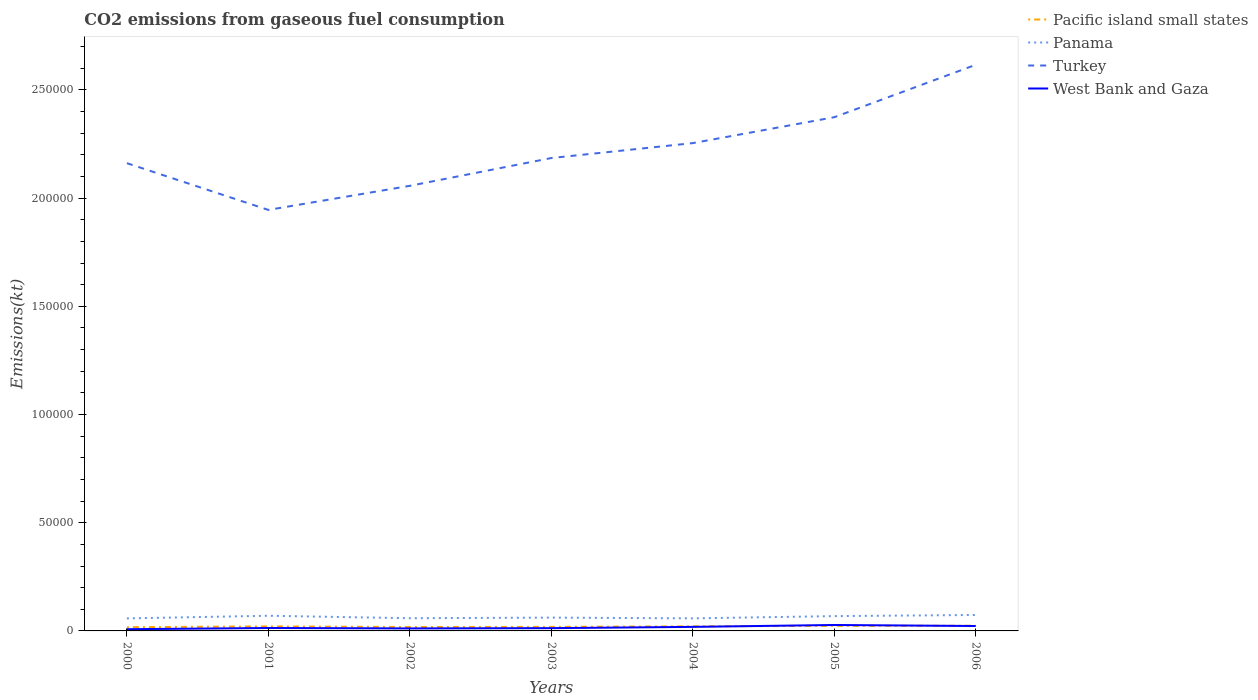How many different coloured lines are there?
Provide a succinct answer. 4. Does the line corresponding to Turkey intersect with the line corresponding to Pacific island small states?
Ensure brevity in your answer.  No. Across all years, what is the maximum amount of CO2 emitted in West Bank and Gaza?
Provide a succinct answer. 792.07. In which year was the amount of CO2 emitted in Turkey maximum?
Keep it short and to the point. 2001. What is the total amount of CO2 emitted in Pacific island small states in the graph?
Your answer should be very brief. -254.8. What is the difference between the highest and the second highest amount of CO2 emitted in West Bank and Gaza?
Keep it short and to the point. 1950.84. Is the amount of CO2 emitted in Turkey strictly greater than the amount of CO2 emitted in West Bank and Gaza over the years?
Your answer should be very brief. No. How many lines are there?
Offer a terse response. 4. Does the graph contain grids?
Your answer should be very brief. No. Where does the legend appear in the graph?
Offer a terse response. Top right. How many legend labels are there?
Keep it short and to the point. 4. How are the legend labels stacked?
Keep it short and to the point. Vertical. What is the title of the graph?
Provide a short and direct response. CO2 emissions from gaseous fuel consumption. Does "Marshall Islands" appear as one of the legend labels in the graph?
Provide a succinct answer. No. What is the label or title of the Y-axis?
Provide a short and direct response. Emissions(kt). What is the Emissions(kt) in Pacific island small states in 2000?
Provide a succinct answer. 1720.84. What is the Emissions(kt) in Panama in 2000?
Offer a very short reply. 5790.19. What is the Emissions(kt) in Turkey in 2000?
Provide a succinct answer. 2.16e+05. What is the Emissions(kt) of West Bank and Gaza in 2000?
Provide a short and direct response. 792.07. What is the Emissions(kt) in Pacific island small states in 2001?
Make the answer very short. 2086.43. What is the Emissions(kt) in Panama in 2001?
Your response must be concise. 7007.64. What is the Emissions(kt) in Turkey in 2001?
Your answer should be very brief. 1.95e+05. What is the Emissions(kt) in West Bank and Gaza in 2001?
Offer a terse response. 1349.46. What is the Emissions(kt) in Pacific island small states in 2002?
Your response must be concise. 1805.78. What is the Emissions(kt) in Panama in 2002?
Keep it short and to the point. 5870.87. What is the Emissions(kt) of Turkey in 2002?
Make the answer very short. 2.06e+05. What is the Emissions(kt) in West Bank and Gaza in 2002?
Your response must be concise. 1155.11. What is the Emissions(kt) in Pacific island small states in 2003?
Make the answer very short. 1864.86. What is the Emissions(kt) of Panama in 2003?
Your response must be concise. 6153.23. What is the Emissions(kt) of Turkey in 2003?
Ensure brevity in your answer.  2.19e+05. What is the Emissions(kt) in West Bank and Gaza in 2003?
Your response must be concise. 1279.78. What is the Emissions(kt) in Pacific island small states in 2004?
Your answer should be very brief. 2119.67. What is the Emissions(kt) in Panama in 2004?
Make the answer very short. 5804.86. What is the Emissions(kt) of Turkey in 2004?
Keep it short and to the point. 2.25e+05. What is the Emissions(kt) of West Bank and Gaza in 2004?
Your answer should be compact. 1866.5. What is the Emissions(kt) in Pacific island small states in 2005?
Make the answer very short. 2356.01. What is the Emissions(kt) in Panama in 2005?
Your answer should be very brief. 6838.95. What is the Emissions(kt) of Turkey in 2005?
Offer a terse response. 2.37e+05. What is the Emissions(kt) in West Bank and Gaza in 2005?
Offer a very short reply. 2742.92. What is the Emissions(kt) of Pacific island small states in 2006?
Offer a terse response. 2396.63. What is the Emissions(kt) in Panama in 2006?
Offer a very short reply. 7370.67. What is the Emissions(kt) in Turkey in 2006?
Your answer should be compact. 2.62e+05. What is the Emissions(kt) of West Bank and Gaza in 2006?
Provide a succinct answer. 2266.21. Across all years, what is the maximum Emissions(kt) in Pacific island small states?
Ensure brevity in your answer.  2396.63. Across all years, what is the maximum Emissions(kt) of Panama?
Offer a very short reply. 7370.67. Across all years, what is the maximum Emissions(kt) of Turkey?
Offer a very short reply. 2.62e+05. Across all years, what is the maximum Emissions(kt) of West Bank and Gaza?
Ensure brevity in your answer.  2742.92. Across all years, what is the minimum Emissions(kt) of Pacific island small states?
Provide a succinct answer. 1720.84. Across all years, what is the minimum Emissions(kt) of Panama?
Your answer should be very brief. 5790.19. Across all years, what is the minimum Emissions(kt) of Turkey?
Offer a terse response. 1.95e+05. Across all years, what is the minimum Emissions(kt) of West Bank and Gaza?
Provide a short and direct response. 792.07. What is the total Emissions(kt) in Pacific island small states in the graph?
Offer a very short reply. 1.44e+04. What is the total Emissions(kt) of Panama in the graph?
Keep it short and to the point. 4.48e+04. What is the total Emissions(kt) in Turkey in the graph?
Give a very brief answer. 1.56e+06. What is the total Emissions(kt) in West Bank and Gaza in the graph?
Ensure brevity in your answer.  1.15e+04. What is the difference between the Emissions(kt) of Pacific island small states in 2000 and that in 2001?
Make the answer very short. -365.59. What is the difference between the Emissions(kt) of Panama in 2000 and that in 2001?
Your response must be concise. -1217.44. What is the difference between the Emissions(kt) in Turkey in 2000 and that in 2001?
Offer a very short reply. 2.16e+04. What is the difference between the Emissions(kt) of West Bank and Gaza in 2000 and that in 2001?
Provide a succinct answer. -557.38. What is the difference between the Emissions(kt) in Pacific island small states in 2000 and that in 2002?
Provide a short and direct response. -84.93. What is the difference between the Emissions(kt) in Panama in 2000 and that in 2002?
Give a very brief answer. -80.67. What is the difference between the Emissions(kt) of Turkey in 2000 and that in 2002?
Offer a very short reply. 1.05e+04. What is the difference between the Emissions(kt) in West Bank and Gaza in 2000 and that in 2002?
Your response must be concise. -363.03. What is the difference between the Emissions(kt) of Pacific island small states in 2000 and that in 2003?
Make the answer very short. -144.02. What is the difference between the Emissions(kt) in Panama in 2000 and that in 2003?
Provide a short and direct response. -363.03. What is the difference between the Emissions(kt) of Turkey in 2000 and that in 2003?
Your answer should be compact. -2372.55. What is the difference between the Emissions(kt) of West Bank and Gaza in 2000 and that in 2003?
Keep it short and to the point. -487.71. What is the difference between the Emissions(kt) in Pacific island small states in 2000 and that in 2004?
Ensure brevity in your answer.  -398.82. What is the difference between the Emissions(kt) of Panama in 2000 and that in 2004?
Provide a short and direct response. -14.67. What is the difference between the Emissions(kt) in Turkey in 2000 and that in 2004?
Provide a succinct answer. -9270.18. What is the difference between the Emissions(kt) of West Bank and Gaza in 2000 and that in 2004?
Keep it short and to the point. -1074.43. What is the difference between the Emissions(kt) of Pacific island small states in 2000 and that in 2005?
Offer a terse response. -635.16. What is the difference between the Emissions(kt) of Panama in 2000 and that in 2005?
Offer a very short reply. -1048.76. What is the difference between the Emissions(kt) of Turkey in 2000 and that in 2005?
Provide a short and direct response. -2.12e+04. What is the difference between the Emissions(kt) of West Bank and Gaza in 2000 and that in 2005?
Offer a very short reply. -1950.84. What is the difference between the Emissions(kt) of Pacific island small states in 2000 and that in 2006?
Your answer should be compact. -675.78. What is the difference between the Emissions(kt) in Panama in 2000 and that in 2006?
Give a very brief answer. -1580.48. What is the difference between the Emissions(kt) of Turkey in 2000 and that in 2006?
Give a very brief answer. -4.55e+04. What is the difference between the Emissions(kt) of West Bank and Gaza in 2000 and that in 2006?
Make the answer very short. -1474.13. What is the difference between the Emissions(kt) of Pacific island small states in 2001 and that in 2002?
Offer a very short reply. 280.65. What is the difference between the Emissions(kt) in Panama in 2001 and that in 2002?
Your answer should be compact. 1136.77. What is the difference between the Emissions(kt) in Turkey in 2001 and that in 2002?
Keep it short and to the point. -1.11e+04. What is the difference between the Emissions(kt) in West Bank and Gaza in 2001 and that in 2002?
Offer a very short reply. 194.35. What is the difference between the Emissions(kt) of Pacific island small states in 2001 and that in 2003?
Your answer should be very brief. 221.57. What is the difference between the Emissions(kt) in Panama in 2001 and that in 2003?
Offer a very short reply. 854.41. What is the difference between the Emissions(kt) in Turkey in 2001 and that in 2003?
Ensure brevity in your answer.  -2.40e+04. What is the difference between the Emissions(kt) in West Bank and Gaza in 2001 and that in 2003?
Provide a short and direct response. 69.67. What is the difference between the Emissions(kt) of Pacific island small states in 2001 and that in 2004?
Provide a short and direct response. -33.24. What is the difference between the Emissions(kt) in Panama in 2001 and that in 2004?
Keep it short and to the point. 1202.78. What is the difference between the Emissions(kt) of Turkey in 2001 and that in 2004?
Make the answer very short. -3.09e+04. What is the difference between the Emissions(kt) in West Bank and Gaza in 2001 and that in 2004?
Ensure brevity in your answer.  -517.05. What is the difference between the Emissions(kt) of Pacific island small states in 2001 and that in 2005?
Your response must be concise. -269.57. What is the difference between the Emissions(kt) of Panama in 2001 and that in 2005?
Give a very brief answer. 168.68. What is the difference between the Emissions(kt) in Turkey in 2001 and that in 2005?
Your response must be concise. -4.28e+04. What is the difference between the Emissions(kt) of West Bank and Gaza in 2001 and that in 2005?
Your answer should be compact. -1393.46. What is the difference between the Emissions(kt) of Pacific island small states in 2001 and that in 2006?
Keep it short and to the point. -310.2. What is the difference between the Emissions(kt) in Panama in 2001 and that in 2006?
Ensure brevity in your answer.  -363.03. What is the difference between the Emissions(kt) in Turkey in 2001 and that in 2006?
Make the answer very short. -6.71e+04. What is the difference between the Emissions(kt) of West Bank and Gaza in 2001 and that in 2006?
Provide a succinct answer. -916.75. What is the difference between the Emissions(kt) of Pacific island small states in 2002 and that in 2003?
Give a very brief answer. -59.08. What is the difference between the Emissions(kt) of Panama in 2002 and that in 2003?
Offer a very short reply. -282.36. What is the difference between the Emissions(kt) of Turkey in 2002 and that in 2003?
Make the answer very short. -1.28e+04. What is the difference between the Emissions(kt) of West Bank and Gaza in 2002 and that in 2003?
Keep it short and to the point. -124.68. What is the difference between the Emissions(kt) of Pacific island small states in 2002 and that in 2004?
Make the answer very short. -313.89. What is the difference between the Emissions(kt) in Panama in 2002 and that in 2004?
Provide a succinct answer. 66.01. What is the difference between the Emissions(kt) in Turkey in 2002 and that in 2004?
Your answer should be very brief. -1.97e+04. What is the difference between the Emissions(kt) of West Bank and Gaza in 2002 and that in 2004?
Make the answer very short. -711.4. What is the difference between the Emissions(kt) in Pacific island small states in 2002 and that in 2005?
Your answer should be compact. -550.23. What is the difference between the Emissions(kt) of Panama in 2002 and that in 2005?
Make the answer very short. -968.09. What is the difference between the Emissions(kt) in Turkey in 2002 and that in 2005?
Keep it short and to the point. -3.17e+04. What is the difference between the Emissions(kt) in West Bank and Gaza in 2002 and that in 2005?
Make the answer very short. -1587.81. What is the difference between the Emissions(kt) in Pacific island small states in 2002 and that in 2006?
Make the answer very short. -590.85. What is the difference between the Emissions(kt) of Panama in 2002 and that in 2006?
Offer a very short reply. -1499.8. What is the difference between the Emissions(kt) in Turkey in 2002 and that in 2006?
Provide a short and direct response. -5.59e+04. What is the difference between the Emissions(kt) of West Bank and Gaza in 2002 and that in 2006?
Give a very brief answer. -1111.1. What is the difference between the Emissions(kt) in Pacific island small states in 2003 and that in 2004?
Your response must be concise. -254.8. What is the difference between the Emissions(kt) in Panama in 2003 and that in 2004?
Give a very brief answer. 348.37. What is the difference between the Emissions(kt) in Turkey in 2003 and that in 2004?
Offer a terse response. -6897.63. What is the difference between the Emissions(kt) of West Bank and Gaza in 2003 and that in 2004?
Offer a very short reply. -586.72. What is the difference between the Emissions(kt) in Pacific island small states in 2003 and that in 2005?
Your response must be concise. -491.14. What is the difference between the Emissions(kt) in Panama in 2003 and that in 2005?
Provide a succinct answer. -685.73. What is the difference between the Emissions(kt) in Turkey in 2003 and that in 2005?
Make the answer very short. -1.89e+04. What is the difference between the Emissions(kt) in West Bank and Gaza in 2003 and that in 2005?
Provide a short and direct response. -1463.13. What is the difference between the Emissions(kt) of Pacific island small states in 2003 and that in 2006?
Offer a very short reply. -531.76. What is the difference between the Emissions(kt) in Panama in 2003 and that in 2006?
Offer a very short reply. -1217.44. What is the difference between the Emissions(kt) in Turkey in 2003 and that in 2006?
Provide a short and direct response. -4.31e+04. What is the difference between the Emissions(kt) in West Bank and Gaza in 2003 and that in 2006?
Make the answer very short. -986.42. What is the difference between the Emissions(kt) in Pacific island small states in 2004 and that in 2005?
Give a very brief answer. -236.34. What is the difference between the Emissions(kt) in Panama in 2004 and that in 2005?
Keep it short and to the point. -1034.09. What is the difference between the Emissions(kt) in Turkey in 2004 and that in 2005?
Make the answer very short. -1.20e+04. What is the difference between the Emissions(kt) in West Bank and Gaza in 2004 and that in 2005?
Ensure brevity in your answer.  -876.41. What is the difference between the Emissions(kt) of Pacific island small states in 2004 and that in 2006?
Give a very brief answer. -276.96. What is the difference between the Emissions(kt) in Panama in 2004 and that in 2006?
Your answer should be very brief. -1565.81. What is the difference between the Emissions(kt) of Turkey in 2004 and that in 2006?
Make the answer very short. -3.62e+04. What is the difference between the Emissions(kt) in West Bank and Gaza in 2004 and that in 2006?
Your answer should be very brief. -399.7. What is the difference between the Emissions(kt) in Pacific island small states in 2005 and that in 2006?
Your response must be concise. -40.62. What is the difference between the Emissions(kt) in Panama in 2005 and that in 2006?
Give a very brief answer. -531.72. What is the difference between the Emissions(kt) in Turkey in 2005 and that in 2006?
Your answer should be compact. -2.42e+04. What is the difference between the Emissions(kt) of West Bank and Gaza in 2005 and that in 2006?
Offer a terse response. 476.71. What is the difference between the Emissions(kt) in Pacific island small states in 2000 and the Emissions(kt) in Panama in 2001?
Ensure brevity in your answer.  -5286.79. What is the difference between the Emissions(kt) of Pacific island small states in 2000 and the Emissions(kt) of Turkey in 2001?
Make the answer very short. -1.93e+05. What is the difference between the Emissions(kt) of Pacific island small states in 2000 and the Emissions(kt) of West Bank and Gaza in 2001?
Your response must be concise. 371.39. What is the difference between the Emissions(kt) in Panama in 2000 and the Emissions(kt) in Turkey in 2001?
Your response must be concise. -1.89e+05. What is the difference between the Emissions(kt) of Panama in 2000 and the Emissions(kt) of West Bank and Gaza in 2001?
Your response must be concise. 4440.74. What is the difference between the Emissions(kt) of Turkey in 2000 and the Emissions(kt) of West Bank and Gaza in 2001?
Make the answer very short. 2.15e+05. What is the difference between the Emissions(kt) of Pacific island small states in 2000 and the Emissions(kt) of Panama in 2002?
Make the answer very short. -4150.02. What is the difference between the Emissions(kt) in Pacific island small states in 2000 and the Emissions(kt) in Turkey in 2002?
Offer a terse response. -2.04e+05. What is the difference between the Emissions(kt) in Pacific island small states in 2000 and the Emissions(kt) in West Bank and Gaza in 2002?
Your answer should be compact. 565.74. What is the difference between the Emissions(kt) in Panama in 2000 and the Emissions(kt) in Turkey in 2002?
Make the answer very short. -2.00e+05. What is the difference between the Emissions(kt) of Panama in 2000 and the Emissions(kt) of West Bank and Gaza in 2002?
Offer a terse response. 4635.09. What is the difference between the Emissions(kt) of Turkey in 2000 and the Emissions(kt) of West Bank and Gaza in 2002?
Make the answer very short. 2.15e+05. What is the difference between the Emissions(kt) of Pacific island small states in 2000 and the Emissions(kt) of Panama in 2003?
Your response must be concise. -4432.38. What is the difference between the Emissions(kt) in Pacific island small states in 2000 and the Emissions(kt) in Turkey in 2003?
Offer a terse response. -2.17e+05. What is the difference between the Emissions(kt) in Pacific island small states in 2000 and the Emissions(kt) in West Bank and Gaza in 2003?
Offer a very short reply. 441.06. What is the difference between the Emissions(kt) in Panama in 2000 and the Emissions(kt) in Turkey in 2003?
Ensure brevity in your answer.  -2.13e+05. What is the difference between the Emissions(kt) of Panama in 2000 and the Emissions(kt) of West Bank and Gaza in 2003?
Your answer should be very brief. 4510.41. What is the difference between the Emissions(kt) of Turkey in 2000 and the Emissions(kt) of West Bank and Gaza in 2003?
Give a very brief answer. 2.15e+05. What is the difference between the Emissions(kt) in Pacific island small states in 2000 and the Emissions(kt) in Panama in 2004?
Ensure brevity in your answer.  -4084.02. What is the difference between the Emissions(kt) in Pacific island small states in 2000 and the Emissions(kt) in Turkey in 2004?
Give a very brief answer. -2.24e+05. What is the difference between the Emissions(kt) of Pacific island small states in 2000 and the Emissions(kt) of West Bank and Gaza in 2004?
Your answer should be compact. -145.66. What is the difference between the Emissions(kt) of Panama in 2000 and the Emissions(kt) of Turkey in 2004?
Make the answer very short. -2.20e+05. What is the difference between the Emissions(kt) in Panama in 2000 and the Emissions(kt) in West Bank and Gaza in 2004?
Your answer should be compact. 3923.69. What is the difference between the Emissions(kt) in Turkey in 2000 and the Emissions(kt) in West Bank and Gaza in 2004?
Provide a succinct answer. 2.14e+05. What is the difference between the Emissions(kt) in Pacific island small states in 2000 and the Emissions(kt) in Panama in 2005?
Your answer should be very brief. -5118.11. What is the difference between the Emissions(kt) in Pacific island small states in 2000 and the Emissions(kt) in Turkey in 2005?
Keep it short and to the point. -2.36e+05. What is the difference between the Emissions(kt) of Pacific island small states in 2000 and the Emissions(kt) of West Bank and Gaza in 2005?
Make the answer very short. -1022.07. What is the difference between the Emissions(kt) in Panama in 2000 and the Emissions(kt) in Turkey in 2005?
Ensure brevity in your answer.  -2.32e+05. What is the difference between the Emissions(kt) in Panama in 2000 and the Emissions(kt) in West Bank and Gaza in 2005?
Your answer should be very brief. 3047.28. What is the difference between the Emissions(kt) in Turkey in 2000 and the Emissions(kt) in West Bank and Gaza in 2005?
Offer a terse response. 2.13e+05. What is the difference between the Emissions(kt) in Pacific island small states in 2000 and the Emissions(kt) in Panama in 2006?
Keep it short and to the point. -5649.83. What is the difference between the Emissions(kt) in Pacific island small states in 2000 and the Emissions(kt) in Turkey in 2006?
Make the answer very short. -2.60e+05. What is the difference between the Emissions(kt) in Pacific island small states in 2000 and the Emissions(kt) in West Bank and Gaza in 2006?
Offer a very short reply. -545.36. What is the difference between the Emissions(kt) in Panama in 2000 and the Emissions(kt) in Turkey in 2006?
Your answer should be compact. -2.56e+05. What is the difference between the Emissions(kt) in Panama in 2000 and the Emissions(kt) in West Bank and Gaza in 2006?
Provide a succinct answer. 3523.99. What is the difference between the Emissions(kt) in Turkey in 2000 and the Emissions(kt) in West Bank and Gaza in 2006?
Your answer should be compact. 2.14e+05. What is the difference between the Emissions(kt) in Pacific island small states in 2001 and the Emissions(kt) in Panama in 2002?
Provide a short and direct response. -3784.43. What is the difference between the Emissions(kt) of Pacific island small states in 2001 and the Emissions(kt) of Turkey in 2002?
Your response must be concise. -2.04e+05. What is the difference between the Emissions(kt) of Pacific island small states in 2001 and the Emissions(kt) of West Bank and Gaza in 2002?
Offer a very short reply. 931.33. What is the difference between the Emissions(kt) of Panama in 2001 and the Emissions(kt) of Turkey in 2002?
Provide a short and direct response. -1.99e+05. What is the difference between the Emissions(kt) in Panama in 2001 and the Emissions(kt) in West Bank and Gaza in 2002?
Give a very brief answer. 5852.53. What is the difference between the Emissions(kt) in Turkey in 2001 and the Emissions(kt) in West Bank and Gaza in 2002?
Keep it short and to the point. 1.93e+05. What is the difference between the Emissions(kt) of Pacific island small states in 2001 and the Emissions(kt) of Panama in 2003?
Your answer should be very brief. -4066.79. What is the difference between the Emissions(kt) of Pacific island small states in 2001 and the Emissions(kt) of Turkey in 2003?
Offer a very short reply. -2.16e+05. What is the difference between the Emissions(kt) in Pacific island small states in 2001 and the Emissions(kt) in West Bank and Gaza in 2003?
Ensure brevity in your answer.  806.65. What is the difference between the Emissions(kt) in Panama in 2001 and the Emissions(kt) in Turkey in 2003?
Make the answer very short. -2.12e+05. What is the difference between the Emissions(kt) of Panama in 2001 and the Emissions(kt) of West Bank and Gaza in 2003?
Give a very brief answer. 5727.85. What is the difference between the Emissions(kt) in Turkey in 2001 and the Emissions(kt) in West Bank and Gaza in 2003?
Provide a succinct answer. 1.93e+05. What is the difference between the Emissions(kt) of Pacific island small states in 2001 and the Emissions(kt) of Panama in 2004?
Keep it short and to the point. -3718.43. What is the difference between the Emissions(kt) of Pacific island small states in 2001 and the Emissions(kt) of Turkey in 2004?
Your response must be concise. -2.23e+05. What is the difference between the Emissions(kt) of Pacific island small states in 2001 and the Emissions(kt) of West Bank and Gaza in 2004?
Your answer should be very brief. 219.93. What is the difference between the Emissions(kt) of Panama in 2001 and the Emissions(kt) of Turkey in 2004?
Keep it short and to the point. -2.18e+05. What is the difference between the Emissions(kt) of Panama in 2001 and the Emissions(kt) of West Bank and Gaza in 2004?
Your answer should be very brief. 5141.13. What is the difference between the Emissions(kt) of Turkey in 2001 and the Emissions(kt) of West Bank and Gaza in 2004?
Provide a succinct answer. 1.93e+05. What is the difference between the Emissions(kt) of Pacific island small states in 2001 and the Emissions(kt) of Panama in 2005?
Offer a very short reply. -4752.52. What is the difference between the Emissions(kt) of Pacific island small states in 2001 and the Emissions(kt) of Turkey in 2005?
Provide a short and direct response. -2.35e+05. What is the difference between the Emissions(kt) of Pacific island small states in 2001 and the Emissions(kt) of West Bank and Gaza in 2005?
Your answer should be compact. -656.48. What is the difference between the Emissions(kt) of Panama in 2001 and the Emissions(kt) of Turkey in 2005?
Provide a short and direct response. -2.30e+05. What is the difference between the Emissions(kt) in Panama in 2001 and the Emissions(kt) in West Bank and Gaza in 2005?
Your answer should be compact. 4264.72. What is the difference between the Emissions(kt) in Turkey in 2001 and the Emissions(kt) in West Bank and Gaza in 2005?
Keep it short and to the point. 1.92e+05. What is the difference between the Emissions(kt) of Pacific island small states in 2001 and the Emissions(kt) of Panama in 2006?
Offer a terse response. -5284.24. What is the difference between the Emissions(kt) of Pacific island small states in 2001 and the Emissions(kt) of Turkey in 2006?
Make the answer very short. -2.60e+05. What is the difference between the Emissions(kt) in Pacific island small states in 2001 and the Emissions(kt) in West Bank and Gaza in 2006?
Ensure brevity in your answer.  -179.77. What is the difference between the Emissions(kt) of Panama in 2001 and the Emissions(kt) of Turkey in 2006?
Your response must be concise. -2.55e+05. What is the difference between the Emissions(kt) of Panama in 2001 and the Emissions(kt) of West Bank and Gaza in 2006?
Offer a very short reply. 4741.43. What is the difference between the Emissions(kt) of Turkey in 2001 and the Emissions(kt) of West Bank and Gaza in 2006?
Keep it short and to the point. 1.92e+05. What is the difference between the Emissions(kt) of Pacific island small states in 2002 and the Emissions(kt) of Panama in 2003?
Offer a very short reply. -4347.45. What is the difference between the Emissions(kt) in Pacific island small states in 2002 and the Emissions(kt) in Turkey in 2003?
Offer a terse response. -2.17e+05. What is the difference between the Emissions(kt) in Pacific island small states in 2002 and the Emissions(kt) in West Bank and Gaza in 2003?
Provide a short and direct response. 526. What is the difference between the Emissions(kt) of Panama in 2002 and the Emissions(kt) of Turkey in 2003?
Your answer should be very brief. -2.13e+05. What is the difference between the Emissions(kt) of Panama in 2002 and the Emissions(kt) of West Bank and Gaza in 2003?
Your answer should be very brief. 4591.08. What is the difference between the Emissions(kt) in Turkey in 2002 and the Emissions(kt) in West Bank and Gaza in 2003?
Provide a short and direct response. 2.04e+05. What is the difference between the Emissions(kt) of Pacific island small states in 2002 and the Emissions(kt) of Panama in 2004?
Your response must be concise. -3999.08. What is the difference between the Emissions(kt) in Pacific island small states in 2002 and the Emissions(kt) in Turkey in 2004?
Offer a terse response. -2.24e+05. What is the difference between the Emissions(kt) in Pacific island small states in 2002 and the Emissions(kt) in West Bank and Gaza in 2004?
Your answer should be compact. -60.72. What is the difference between the Emissions(kt) in Panama in 2002 and the Emissions(kt) in Turkey in 2004?
Your answer should be compact. -2.20e+05. What is the difference between the Emissions(kt) of Panama in 2002 and the Emissions(kt) of West Bank and Gaza in 2004?
Provide a short and direct response. 4004.36. What is the difference between the Emissions(kt) in Turkey in 2002 and the Emissions(kt) in West Bank and Gaza in 2004?
Give a very brief answer. 2.04e+05. What is the difference between the Emissions(kt) in Pacific island small states in 2002 and the Emissions(kt) in Panama in 2005?
Keep it short and to the point. -5033.18. What is the difference between the Emissions(kt) of Pacific island small states in 2002 and the Emissions(kt) of Turkey in 2005?
Provide a short and direct response. -2.36e+05. What is the difference between the Emissions(kt) of Pacific island small states in 2002 and the Emissions(kt) of West Bank and Gaza in 2005?
Ensure brevity in your answer.  -937.14. What is the difference between the Emissions(kt) in Panama in 2002 and the Emissions(kt) in Turkey in 2005?
Keep it short and to the point. -2.32e+05. What is the difference between the Emissions(kt) in Panama in 2002 and the Emissions(kt) in West Bank and Gaza in 2005?
Ensure brevity in your answer.  3127.95. What is the difference between the Emissions(kt) in Turkey in 2002 and the Emissions(kt) in West Bank and Gaza in 2005?
Your answer should be very brief. 2.03e+05. What is the difference between the Emissions(kt) of Pacific island small states in 2002 and the Emissions(kt) of Panama in 2006?
Provide a short and direct response. -5564.89. What is the difference between the Emissions(kt) in Pacific island small states in 2002 and the Emissions(kt) in Turkey in 2006?
Provide a short and direct response. -2.60e+05. What is the difference between the Emissions(kt) of Pacific island small states in 2002 and the Emissions(kt) of West Bank and Gaza in 2006?
Your response must be concise. -460.43. What is the difference between the Emissions(kt) in Panama in 2002 and the Emissions(kt) in Turkey in 2006?
Your answer should be very brief. -2.56e+05. What is the difference between the Emissions(kt) of Panama in 2002 and the Emissions(kt) of West Bank and Gaza in 2006?
Offer a very short reply. 3604.66. What is the difference between the Emissions(kt) in Turkey in 2002 and the Emissions(kt) in West Bank and Gaza in 2006?
Give a very brief answer. 2.03e+05. What is the difference between the Emissions(kt) of Pacific island small states in 2003 and the Emissions(kt) of Panama in 2004?
Your response must be concise. -3940. What is the difference between the Emissions(kt) in Pacific island small states in 2003 and the Emissions(kt) in Turkey in 2004?
Your answer should be compact. -2.24e+05. What is the difference between the Emissions(kt) of Pacific island small states in 2003 and the Emissions(kt) of West Bank and Gaza in 2004?
Offer a terse response. -1.64. What is the difference between the Emissions(kt) of Panama in 2003 and the Emissions(kt) of Turkey in 2004?
Provide a succinct answer. -2.19e+05. What is the difference between the Emissions(kt) in Panama in 2003 and the Emissions(kt) in West Bank and Gaza in 2004?
Provide a succinct answer. 4286.72. What is the difference between the Emissions(kt) in Turkey in 2003 and the Emissions(kt) in West Bank and Gaza in 2004?
Keep it short and to the point. 2.17e+05. What is the difference between the Emissions(kt) in Pacific island small states in 2003 and the Emissions(kt) in Panama in 2005?
Your answer should be compact. -4974.09. What is the difference between the Emissions(kt) of Pacific island small states in 2003 and the Emissions(kt) of Turkey in 2005?
Your answer should be compact. -2.36e+05. What is the difference between the Emissions(kt) of Pacific island small states in 2003 and the Emissions(kt) of West Bank and Gaza in 2005?
Your response must be concise. -878.05. What is the difference between the Emissions(kt) in Panama in 2003 and the Emissions(kt) in Turkey in 2005?
Give a very brief answer. -2.31e+05. What is the difference between the Emissions(kt) of Panama in 2003 and the Emissions(kt) of West Bank and Gaza in 2005?
Provide a succinct answer. 3410.31. What is the difference between the Emissions(kt) of Turkey in 2003 and the Emissions(kt) of West Bank and Gaza in 2005?
Offer a terse response. 2.16e+05. What is the difference between the Emissions(kt) of Pacific island small states in 2003 and the Emissions(kt) of Panama in 2006?
Your answer should be compact. -5505.81. What is the difference between the Emissions(kt) in Pacific island small states in 2003 and the Emissions(kt) in Turkey in 2006?
Provide a short and direct response. -2.60e+05. What is the difference between the Emissions(kt) of Pacific island small states in 2003 and the Emissions(kt) of West Bank and Gaza in 2006?
Keep it short and to the point. -401.34. What is the difference between the Emissions(kt) of Panama in 2003 and the Emissions(kt) of Turkey in 2006?
Provide a short and direct response. -2.55e+05. What is the difference between the Emissions(kt) of Panama in 2003 and the Emissions(kt) of West Bank and Gaza in 2006?
Give a very brief answer. 3887.02. What is the difference between the Emissions(kt) in Turkey in 2003 and the Emissions(kt) in West Bank and Gaza in 2006?
Offer a very short reply. 2.16e+05. What is the difference between the Emissions(kt) of Pacific island small states in 2004 and the Emissions(kt) of Panama in 2005?
Make the answer very short. -4719.29. What is the difference between the Emissions(kt) of Pacific island small states in 2004 and the Emissions(kt) of Turkey in 2005?
Offer a terse response. -2.35e+05. What is the difference between the Emissions(kt) in Pacific island small states in 2004 and the Emissions(kt) in West Bank and Gaza in 2005?
Offer a terse response. -623.25. What is the difference between the Emissions(kt) in Panama in 2004 and the Emissions(kt) in Turkey in 2005?
Make the answer very short. -2.32e+05. What is the difference between the Emissions(kt) in Panama in 2004 and the Emissions(kt) in West Bank and Gaza in 2005?
Provide a succinct answer. 3061.95. What is the difference between the Emissions(kt) in Turkey in 2004 and the Emissions(kt) in West Bank and Gaza in 2005?
Keep it short and to the point. 2.23e+05. What is the difference between the Emissions(kt) of Pacific island small states in 2004 and the Emissions(kt) of Panama in 2006?
Ensure brevity in your answer.  -5251. What is the difference between the Emissions(kt) in Pacific island small states in 2004 and the Emissions(kt) in Turkey in 2006?
Offer a very short reply. -2.59e+05. What is the difference between the Emissions(kt) in Pacific island small states in 2004 and the Emissions(kt) in West Bank and Gaza in 2006?
Provide a short and direct response. -146.54. What is the difference between the Emissions(kt) in Panama in 2004 and the Emissions(kt) in Turkey in 2006?
Make the answer very short. -2.56e+05. What is the difference between the Emissions(kt) of Panama in 2004 and the Emissions(kt) of West Bank and Gaza in 2006?
Your answer should be compact. 3538.66. What is the difference between the Emissions(kt) in Turkey in 2004 and the Emissions(kt) in West Bank and Gaza in 2006?
Provide a short and direct response. 2.23e+05. What is the difference between the Emissions(kt) of Pacific island small states in 2005 and the Emissions(kt) of Panama in 2006?
Your response must be concise. -5014.66. What is the difference between the Emissions(kt) of Pacific island small states in 2005 and the Emissions(kt) of Turkey in 2006?
Ensure brevity in your answer.  -2.59e+05. What is the difference between the Emissions(kt) in Pacific island small states in 2005 and the Emissions(kt) in West Bank and Gaza in 2006?
Offer a very short reply. 89.8. What is the difference between the Emissions(kt) in Panama in 2005 and the Emissions(kt) in Turkey in 2006?
Keep it short and to the point. -2.55e+05. What is the difference between the Emissions(kt) in Panama in 2005 and the Emissions(kt) in West Bank and Gaza in 2006?
Keep it short and to the point. 4572.75. What is the difference between the Emissions(kt) of Turkey in 2005 and the Emissions(kt) of West Bank and Gaza in 2006?
Your response must be concise. 2.35e+05. What is the average Emissions(kt) of Pacific island small states per year?
Keep it short and to the point. 2050.03. What is the average Emissions(kt) of Panama per year?
Provide a short and direct response. 6405.2. What is the average Emissions(kt) in Turkey per year?
Keep it short and to the point. 2.23e+05. What is the average Emissions(kt) in West Bank and Gaza per year?
Keep it short and to the point. 1636.01. In the year 2000, what is the difference between the Emissions(kt) of Pacific island small states and Emissions(kt) of Panama?
Provide a short and direct response. -4069.35. In the year 2000, what is the difference between the Emissions(kt) in Pacific island small states and Emissions(kt) in Turkey?
Offer a terse response. -2.14e+05. In the year 2000, what is the difference between the Emissions(kt) of Pacific island small states and Emissions(kt) of West Bank and Gaza?
Keep it short and to the point. 928.77. In the year 2000, what is the difference between the Emissions(kt) of Panama and Emissions(kt) of Turkey?
Offer a terse response. -2.10e+05. In the year 2000, what is the difference between the Emissions(kt) of Panama and Emissions(kt) of West Bank and Gaza?
Your response must be concise. 4998.12. In the year 2000, what is the difference between the Emissions(kt) in Turkey and Emissions(kt) in West Bank and Gaza?
Your answer should be very brief. 2.15e+05. In the year 2001, what is the difference between the Emissions(kt) in Pacific island small states and Emissions(kt) in Panama?
Provide a short and direct response. -4921.2. In the year 2001, what is the difference between the Emissions(kt) of Pacific island small states and Emissions(kt) of Turkey?
Make the answer very short. -1.92e+05. In the year 2001, what is the difference between the Emissions(kt) of Pacific island small states and Emissions(kt) of West Bank and Gaza?
Your answer should be compact. 736.98. In the year 2001, what is the difference between the Emissions(kt) of Panama and Emissions(kt) of Turkey?
Your answer should be very brief. -1.88e+05. In the year 2001, what is the difference between the Emissions(kt) of Panama and Emissions(kt) of West Bank and Gaza?
Give a very brief answer. 5658.18. In the year 2001, what is the difference between the Emissions(kt) in Turkey and Emissions(kt) in West Bank and Gaza?
Offer a very short reply. 1.93e+05. In the year 2002, what is the difference between the Emissions(kt) in Pacific island small states and Emissions(kt) in Panama?
Offer a very short reply. -4065.09. In the year 2002, what is the difference between the Emissions(kt) of Pacific island small states and Emissions(kt) of Turkey?
Provide a succinct answer. -2.04e+05. In the year 2002, what is the difference between the Emissions(kt) in Pacific island small states and Emissions(kt) in West Bank and Gaza?
Provide a short and direct response. 650.67. In the year 2002, what is the difference between the Emissions(kt) of Panama and Emissions(kt) of Turkey?
Your answer should be compact. -2.00e+05. In the year 2002, what is the difference between the Emissions(kt) of Panama and Emissions(kt) of West Bank and Gaza?
Offer a very short reply. 4715.76. In the year 2002, what is the difference between the Emissions(kt) of Turkey and Emissions(kt) of West Bank and Gaza?
Give a very brief answer. 2.05e+05. In the year 2003, what is the difference between the Emissions(kt) of Pacific island small states and Emissions(kt) of Panama?
Offer a very short reply. -4288.36. In the year 2003, what is the difference between the Emissions(kt) of Pacific island small states and Emissions(kt) of Turkey?
Offer a terse response. -2.17e+05. In the year 2003, what is the difference between the Emissions(kt) of Pacific island small states and Emissions(kt) of West Bank and Gaza?
Provide a succinct answer. 585.08. In the year 2003, what is the difference between the Emissions(kt) in Panama and Emissions(kt) in Turkey?
Provide a succinct answer. -2.12e+05. In the year 2003, what is the difference between the Emissions(kt) in Panama and Emissions(kt) in West Bank and Gaza?
Your answer should be compact. 4873.44. In the year 2003, what is the difference between the Emissions(kt) of Turkey and Emissions(kt) of West Bank and Gaza?
Provide a short and direct response. 2.17e+05. In the year 2004, what is the difference between the Emissions(kt) in Pacific island small states and Emissions(kt) in Panama?
Give a very brief answer. -3685.19. In the year 2004, what is the difference between the Emissions(kt) in Pacific island small states and Emissions(kt) in Turkey?
Your answer should be very brief. -2.23e+05. In the year 2004, what is the difference between the Emissions(kt) in Pacific island small states and Emissions(kt) in West Bank and Gaza?
Your response must be concise. 253.16. In the year 2004, what is the difference between the Emissions(kt) in Panama and Emissions(kt) in Turkey?
Your answer should be very brief. -2.20e+05. In the year 2004, what is the difference between the Emissions(kt) of Panama and Emissions(kt) of West Bank and Gaza?
Provide a succinct answer. 3938.36. In the year 2004, what is the difference between the Emissions(kt) of Turkey and Emissions(kt) of West Bank and Gaza?
Provide a short and direct response. 2.24e+05. In the year 2005, what is the difference between the Emissions(kt) in Pacific island small states and Emissions(kt) in Panama?
Give a very brief answer. -4482.95. In the year 2005, what is the difference between the Emissions(kt) of Pacific island small states and Emissions(kt) of Turkey?
Give a very brief answer. -2.35e+05. In the year 2005, what is the difference between the Emissions(kt) in Pacific island small states and Emissions(kt) in West Bank and Gaza?
Make the answer very short. -386.91. In the year 2005, what is the difference between the Emissions(kt) in Panama and Emissions(kt) in Turkey?
Provide a short and direct response. -2.31e+05. In the year 2005, what is the difference between the Emissions(kt) of Panama and Emissions(kt) of West Bank and Gaza?
Your answer should be compact. 4096.04. In the year 2005, what is the difference between the Emissions(kt) of Turkey and Emissions(kt) of West Bank and Gaza?
Offer a terse response. 2.35e+05. In the year 2006, what is the difference between the Emissions(kt) in Pacific island small states and Emissions(kt) in Panama?
Make the answer very short. -4974.04. In the year 2006, what is the difference between the Emissions(kt) of Pacific island small states and Emissions(kt) of Turkey?
Provide a short and direct response. -2.59e+05. In the year 2006, what is the difference between the Emissions(kt) of Pacific island small states and Emissions(kt) of West Bank and Gaza?
Give a very brief answer. 130.42. In the year 2006, what is the difference between the Emissions(kt) of Panama and Emissions(kt) of Turkey?
Your answer should be very brief. -2.54e+05. In the year 2006, what is the difference between the Emissions(kt) in Panama and Emissions(kt) in West Bank and Gaza?
Provide a short and direct response. 5104.46. In the year 2006, what is the difference between the Emissions(kt) of Turkey and Emissions(kt) of West Bank and Gaza?
Offer a very short reply. 2.59e+05. What is the ratio of the Emissions(kt) in Pacific island small states in 2000 to that in 2001?
Your answer should be very brief. 0.82. What is the ratio of the Emissions(kt) in Panama in 2000 to that in 2001?
Keep it short and to the point. 0.83. What is the ratio of the Emissions(kt) of Turkey in 2000 to that in 2001?
Provide a succinct answer. 1.11. What is the ratio of the Emissions(kt) in West Bank and Gaza in 2000 to that in 2001?
Offer a very short reply. 0.59. What is the ratio of the Emissions(kt) of Pacific island small states in 2000 to that in 2002?
Your response must be concise. 0.95. What is the ratio of the Emissions(kt) in Panama in 2000 to that in 2002?
Your response must be concise. 0.99. What is the ratio of the Emissions(kt) of Turkey in 2000 to that in 2002?
Your answer should be very brief. 1.05. What is the ratio of the Emissions(kt) in West Bank and Gaza in 2000 to that in 2002?
Give a very brief answer. 0.69. What is the ratio of the Emissions(kt) in Pacific island small states in 2000 to that in 2003?
Keep it short and to the point. 0.92. What is the ratio of the Emissions(kt) in Panama in 2000 to that in 2003?
Give a very brief answer. 0.94. What is the ratio of the Emissions(kt) of Turkey in 2000 to that in 2003?
Your answer should be very brief. 0.99. What is the ratio of the Emissions(kt) in West Bank and Gaza in 2000 to that in 2003?
Your answer should be compact. 0.62. What is the ratio of the Emissions(kt) of Pacific island small states in 2000 to that in 2004?
Make the answer very short. 0.81. What is the ratio of the Emissions(kt) in Turkey in 2000 to that in 2004?
Ensure brevity in your answer.  0.96. What is the ratio of the Emissions(kt) of West Bank and Gaza in 2000 to that in 2004?
Offer a terse response. 0.42. What is the ratio of the Emissions(kt) of Pacific island small states in 2000 to that in 2005?
Ensure brevity in your answer.  0.73. What is the ratio of the Emissions(kt) of Panama in 2000 to that in 2005?
Your answer should be very brief. 0.85. What is the ratio of the Emissions(kt) of Turkey in 2000 to that in 2005?
Give a very brief answer. 0.91. What is the ratio of the Emissions(kt) of West Bank and Gaza in 2000 to that in 2005?
Your answer should be very brief. 0.29. What is the ratio of the Emissions(kt) of Pacific island small states in 2000 to that in 2006?
Keep it short and to the point. 0.72. What is the ratio of the Emissions(kt) in Panama in 2000 to that in 2006?
Offer a very short reply. 0.79. What is the ratio of the Emissions(kt) of Turkey in 2000 to that in 2006?
Offer a very short reply. 0.83. What is the ratio of the Emissions(kt) of West Bank and Gaza in 2000 to that in 2006?
Provide a short and direct response. 0.35. What is the ratio of the Emissions(kt) of Pacific island small states in 2001 to that in 2002?
Make the answer very short. 1.16. What is the ratio of the Emissions(kt) of Panama in 2001 to that in 2002?
Offer a terse response. 1.19. What is the ratio of the Emissions(kt) of Turkey in 2001 to that in 2002?
Make the answer very short. 0.95. What is the ratio of the Emissions(kt) in West Bank and Gaza in 2001 to that in 2002?
Offer a very short reply. 1.17. What is the ratio of the Emissions(kt) in Pacific island small states in 2001 to that in 2003?
Your response must be concise. 1.12. What is the ratio of the Emissions(kt) in Panama in 2001 to that in 2003?
Keep it short and to the point. 1.14. What is the ratio of the Emissions(kt) in Turkey in 2001 to that in 2003?
Your response must be concise. 0.89. What is the ratio of the Emissions(kt) of West Bank and Gaza in 2001 to that in 2003?
Make the answer very short. 1.05. What is the ratio of the Emissions(kt) of Pacific island small states in 2001 to that in 2004?
Keep it short and to the point. 0.98. What is the ratio of the Emissions(kt) of Panama in 2001 to that in 2004?
Provide a succinct answer. 1.21. What is the ratio of the Emissions(kt) in Turkey in 2001 to that in 2004?
Your response must be concise. 0.86. What is the ratio of the Emissions(kt) of West Bank and Gaza in 2001 to that in 2004?
Your response must be concise. 0.72. What is the ratio of the Emissions(kt) of Pacific island small states in 2001 to that in 2005?
Keep it short and to the point. 0.89. What is the ratio of the Emissions(kt) in Panama in 2001 to that in 2005?
Your answer should be very brief. 1.02. What is the ratio of the Emissions(kt) of Turkey in 2001 to that in 2005?
Give a very brief answer. 0.82. What is the ratio of the Emissions(kt) in West Bank and Gaza in 2001 to that in 2005?
Offer a very short reply. 0.49. What is the ratio of the Emissions(kt) of Pacific island small states in 2001 to that in 2006?
Your answer should be very brief. 0.87. What is the ratio of the Emissions(kt) in Panama in 2001 to that in 2006?
Keep it short and to the point. 0.95. What is the ratio of the Emissions(kt) of Turkey in 2001 to that in 2006?
Provide a succinct answer. 0.74. What is the ratio of the Emissions(kt) of West Bank and Gaza in 2001 to that in 2006?
Your answer should be compact. 0.6. What is the ratio of the Emissions(kt) in Pacific island small states in 2002 to that in 2003?
Give a very brief answer. 0.97. What is the ratio of the Emissions(kt) of Panama in 2002 to that in 2003?
Provide a short and direct response. 0.95. What is the ratio of the Emissions(kt) in Turkey in 2002 to that in 2003?
Your response must be concise. 0.94. What is the ratio of the Emissions(kt) of West Bank and Gaza in 2002 to that in 2003?
Your response must be concise. 0.9. What is the ratio of the Emissions(kt) in Pacific island small states in 2002 to that in 2004?
Offer a terse response. 0.85. What is the ratio of the Emissions(kt) of Panama in 2002 to that in 2004?
Your answer should be very brief. 1.01. What is the ratio of the Emissions(kt) of Turkey in 2002 to that in 2004?
Offer a very short reply. 0.91. What is the ratio of the Emissions(kt) in West Bank and Gaza in 2002 to that in 2004?
Your answer should be compact. 0.62. What is the ratio of the Emissions(kt) of Pacific island small states in 2002 to that in 2005?
Ensure brevity in your answer.  0.77. What is the ratio of the Emissions(kt) of Panama in 2002 to that in 2005?
Give a very brief answer. 0.86. What is the ratio of the Emissions(kt) in Turkey in 2002 to that in 2005?
Offer a terse response. 0.87. What is the ratio of the Emissions(kt) of West Bank and Gaza in 2002 to that in 2005?
Your answer should be compact. 0.42. What is the ratio of the Emissions(kt) in Pacific island small states in 2002 to that in 2006?
Make the answer very short. 0.75. What is the ratio of the Emissions(kt) of Panama in 2002 to that in 2006?
Your response must be concise. 0.8. What is the ratio of the Emissions(kt) in Turkey in 2002 to that in 2006?
Offer a very short reply. 0.79. What is the ratio of the Emissions(kt) in West Bank and Gaza in 2002 to that in 2006?
Keep it short and to the point. 0.51. What is the ratio of the Emissions(kt) of Pacific island small states in 2003 to that in 2004?
Your answer should be compact. 0.88. What is the ratio of the Emissions(kt) of Panama in 2003 to that in 2004?
Your answer should be compact. 1.06. What is the ratio of the Emissions(kt) of Turkey in 2003 to that in 2004?
Provide a short and direct response. 0.97. What is the ratio of the Emissions(kt) of West Bank and Gaza in 2003 to that in 2004?
Ensure brevity in your answer.  0.69. What is the ratio of the Emissions(kt) of Pacific island small states in 2003 to that in 2005?
Your response must be concise. 0.79. What is the ratio of the Emissions(kt) in Panama in 2003 to that in 2005?
Keep it short and to the point. 0.9. What is the ratio of the Emissions(kt) in Turkey in 2003 to that in 2005?
Provide a short and direct response. 0.92. What is the ratio of the Emissions(kt) in West Bank and Gaza in 2003 to that in 2005?
Keep it short and to the point. 0.47. What is the ratio of the Emissions(kt) of Pacific island small states in 2003 to that in 2006?
Provide a short and direct response. 0.78. What is the ratio of the Emissions(kt) of Panama in 2003 to that in 2006?
Give a very brief answer. 0.83. What is the ratio of the Emissions(kt) in Turkey in 2003 to that in 2006?
Your answer should be compact. 0.84. What is the ratio of the Emissions(kt) of West Bank and Gaza in 2003 to that in 2006?
Give a very brief answer. 0.56. What is the ratio of the Emissions(kt) in Pacific island small states in 2004 to that in 2005?
Make the answer very short. 0.9. What is the ratio of the Emissions(kt) of Panama in 2004 to that in 2005?
Offer a terse response. 0.85. What is the ratio of the Emissions(kt) in Turkey in 2004 to that in 2005?
Offer a terse response. 0.95. What is the ratio of the Emissions(kt) in West Bank and Gaza in 2004 to that in 2005?
Ensure brevity in your answer.  0.68. What is the ratio of the Emissions(kt) of Pacific island small states in 2004 to that in 2006?
Make the answer very short. 0.88. What is the ratio of the Emissions(kt) in Panama in 2004 to that in 2006?
Your answer should be compact. 0.79. What is the ratio of the Emissions(kt) of Turkey in 2004 to that in 2006?
Your response must be concise. 0.86. What is the ratio of the Emissions(kt) in West Bank and Gaza in 2004 to that in 2006?
Your answer should be compact. 0.82. What is the ratio of the Emissions(kt) of Pacific island small states in 2005 to that in 2006?
Your answer should be compact. 0.98. What is the ratio of the Emissions(kt) of Panama in 2005 to that in 2006?
Your response must be concise. 0.93. What is the ratio of the Emissions(kt) of Turkey in 2005 to that in 2006?
Ensure brevity in your answer.  0.91. What is the ratio of the Emissions(kt) of West Bank and Gaza in 2005 to that in 2006?
Provide a succinct answer. 1.21. What is the difference between the highest and the second highest Emissions(kt) in Pacific island small states?
Your response must be concise. 40.62. What is the difference between the highest and the second highest Emissions(kt) of Panama?
Offer a very short reply. 363.03. What is the difference between the highest and the second highest Emissions(kt) of Turkey?
Give a very brief answer. 2.42e+04. What is the difference between the highest and the second highest Emissions(kt) of West Bank and Gaza?
Keep it short and to the point. 476.71. What is the difference between the highest and the lowest Emissions(kt) in Pacific island small states?
Offer a terse response. 675.78. What is the difference between the highest and the lowest Emissions(kt) of Panama?
Ensure brevity in your answer.  1580.48. What is the difference between the highest and the lowest Emissions(kt) in Turkey?
Offer a terse response. 6.71e+04. What is the difference between the highest and the lowest Emissions(kt) in West Bank and Gaza?
Ensure brevity in your answer.  1950.84. 